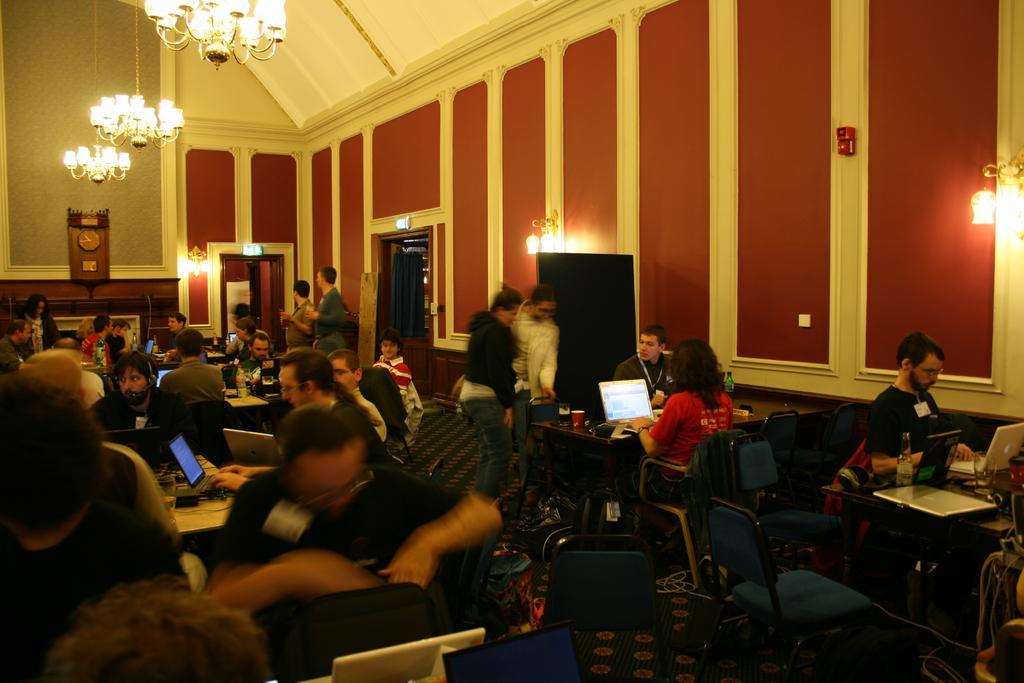How would you summarize this image in a sentence or two? In this image we can see people sitting on the chairs, tables, laptops, lights, a wall and a clock. 